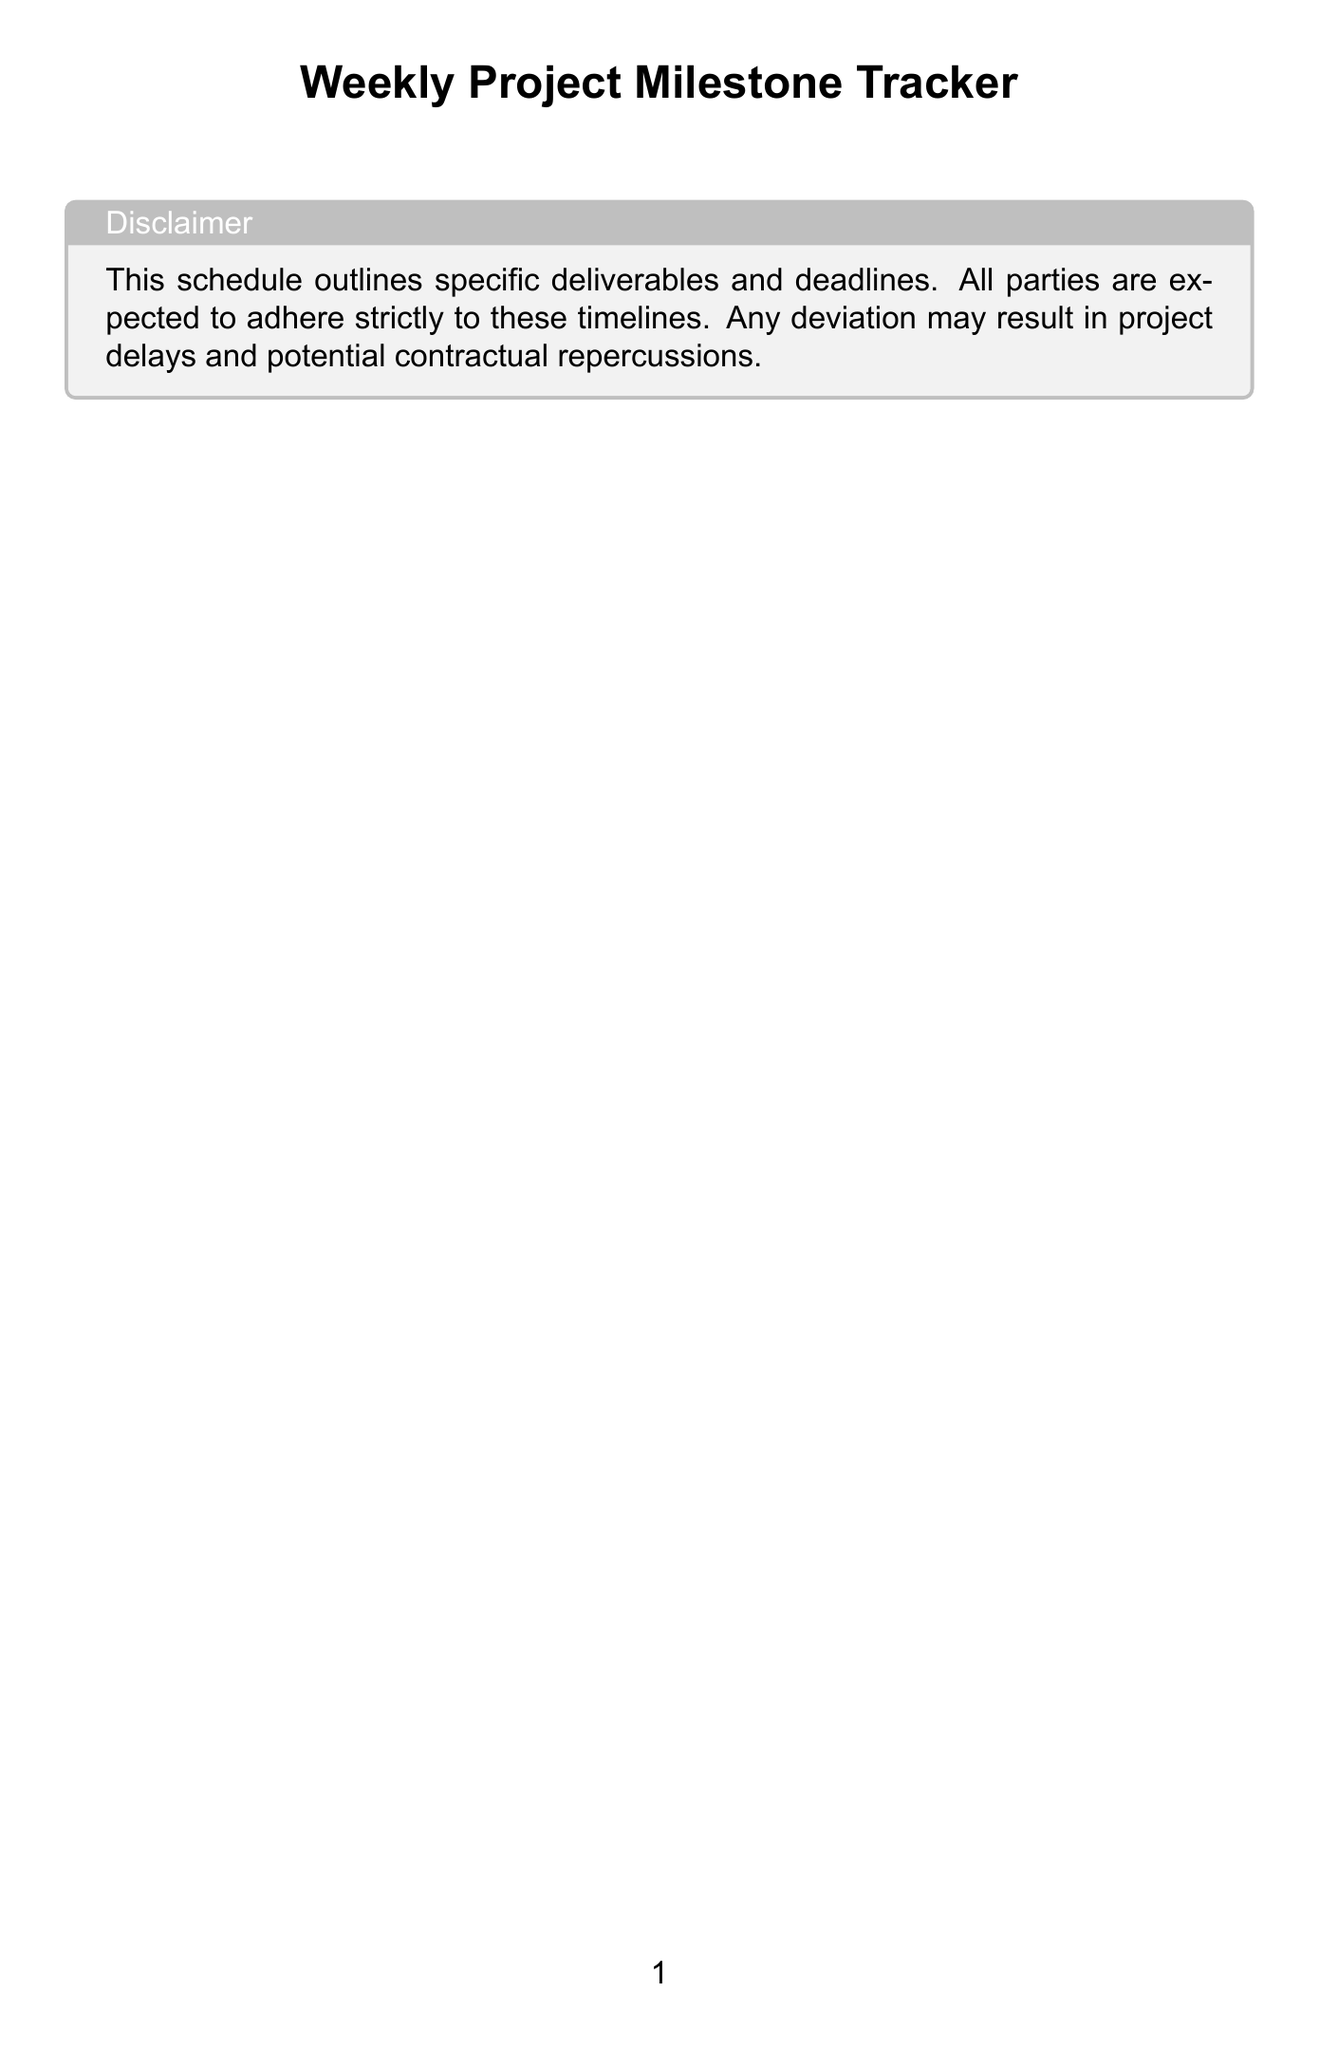What is the deliverable for the Project Kick-off Meeting? The deliverable is the outcome expected from the Project Kick-off Meeting, which is specified in the document.
Answer: Meeting minutes with action items What is the deadline for the Requirements Gathering task? The deadline is the specific day and time by which the Requirements Gathering task must be completed, as stated in the document.
Answer: Friday, 3:00 PM In which week is the Design Review scheduled? This question relates to the week numbering of tasks outlined in the schedule.
Answer: Week 3 What is the final deliverable due in Week 8? The final deliverable provides information on what needs to be submitted during the last week of the project.
Answer: Signed-off project deliverables and handover report How many design concepts are to be delivered in Week 2? The question addresses a specific quantity outlined in the document pertaining to design concepts.
Answer: Three design concepts in PDF format Which task in Week 5 has a deadline of 12:00 PM? This question seeks to identify a specific task and its related deadline within Week 5.
Answer: Backend Development - Phase 2 What is one deliverable due on Tuesday of Week 7? This question asks for a specific deliverable that is required on a particular day in Week 7.
Answer: Optimized code and performance metrics report When is the Integration Testing deliverable due? This question looks for the specific deadline associated with the Integration Testing task as outlined in the document.
Answer: Friday, 5:00 PM What must be delivered by Wednesday of Week 6? This question addresses the required deliverable by a specific day and week outlined in the document.
Answer: Completed user dashboard and settings pages 